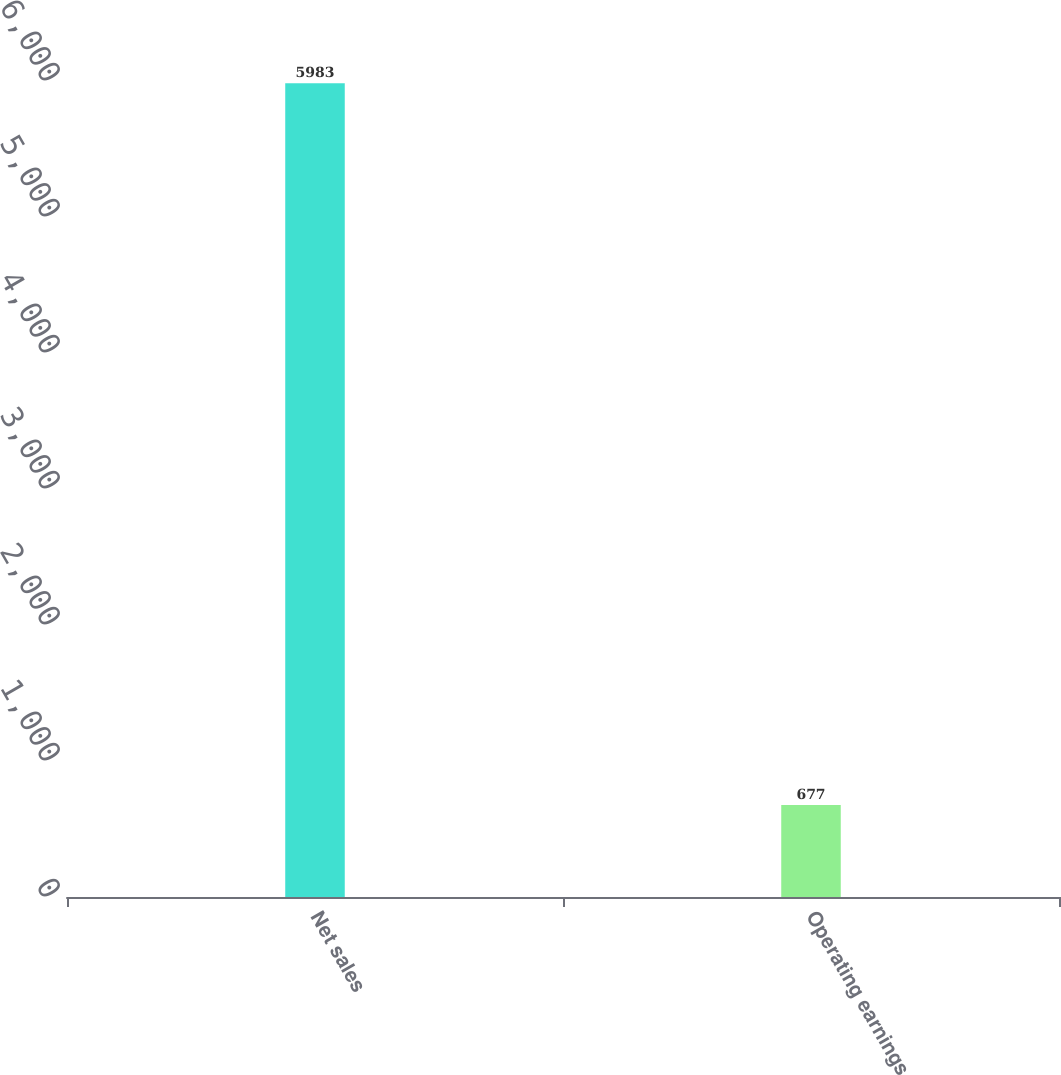<chart> <loc_0><loc_0><loc_500><loc_500><bar_chart><fcel>Net sales<fcel>Operating earnings<nl><fcel>5983<fcel>677<nl></chart> 